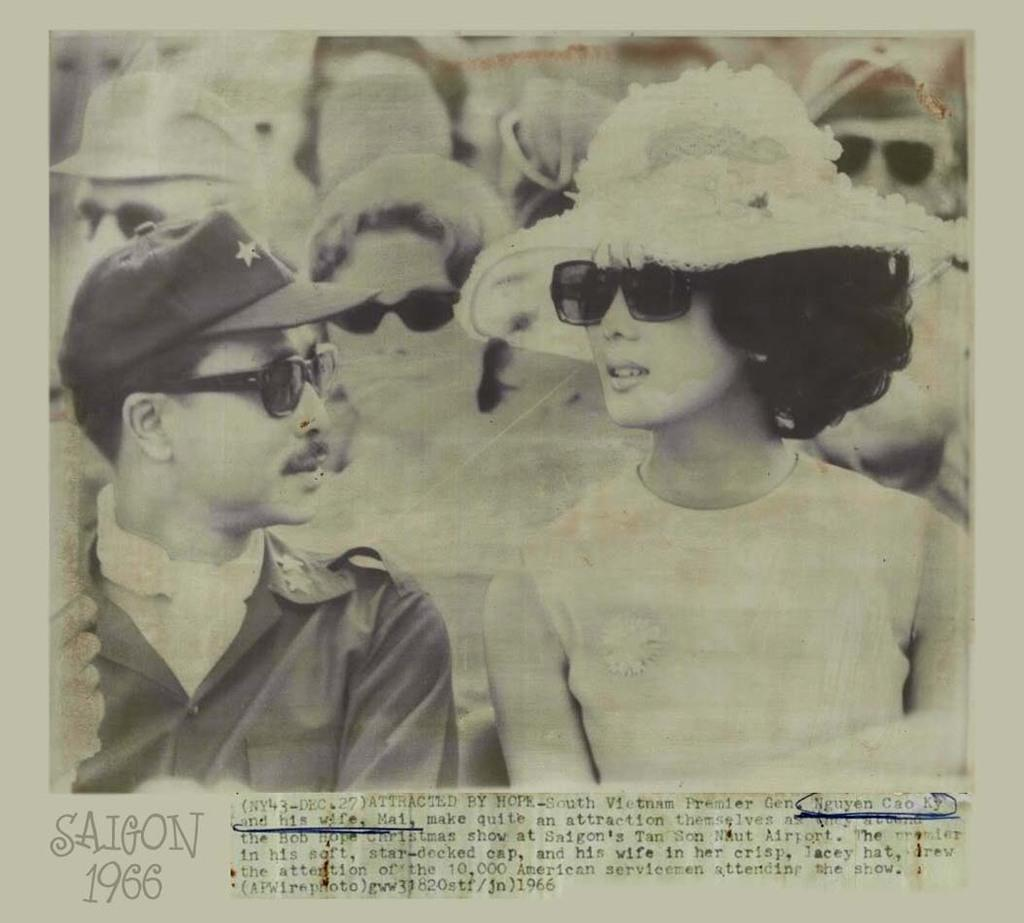What is the main subject of the image? There is an article in the image. What can be seen within the article? There is a black and white picture in the article. Who or what is depicted in the black and white picture? There are people in the black and white picture. Can you describe the seashore in the image? There is no seashore present in the image; it features an article with a black and white picture of people. What type of knot is being tied by the people in the image? There is no knot-tying activity depicted in the image; it features an article with a black and white picture of people. 